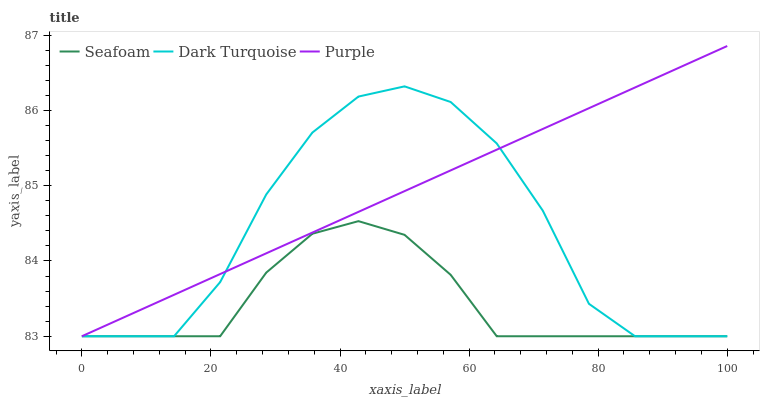Does Dark Turquoise have the minimum area under the curve?
Answer yes or no. No. Does Dark Turquoise have the maximum area under the curve?
Answer yes or no. No. Is Seafoam the smoothest?
Answer yes or no. No. Is Seafoam the roughest?
Answer yes or no. No. Does Dark Turquoise have the highest value?
Answer yes or no. No. 